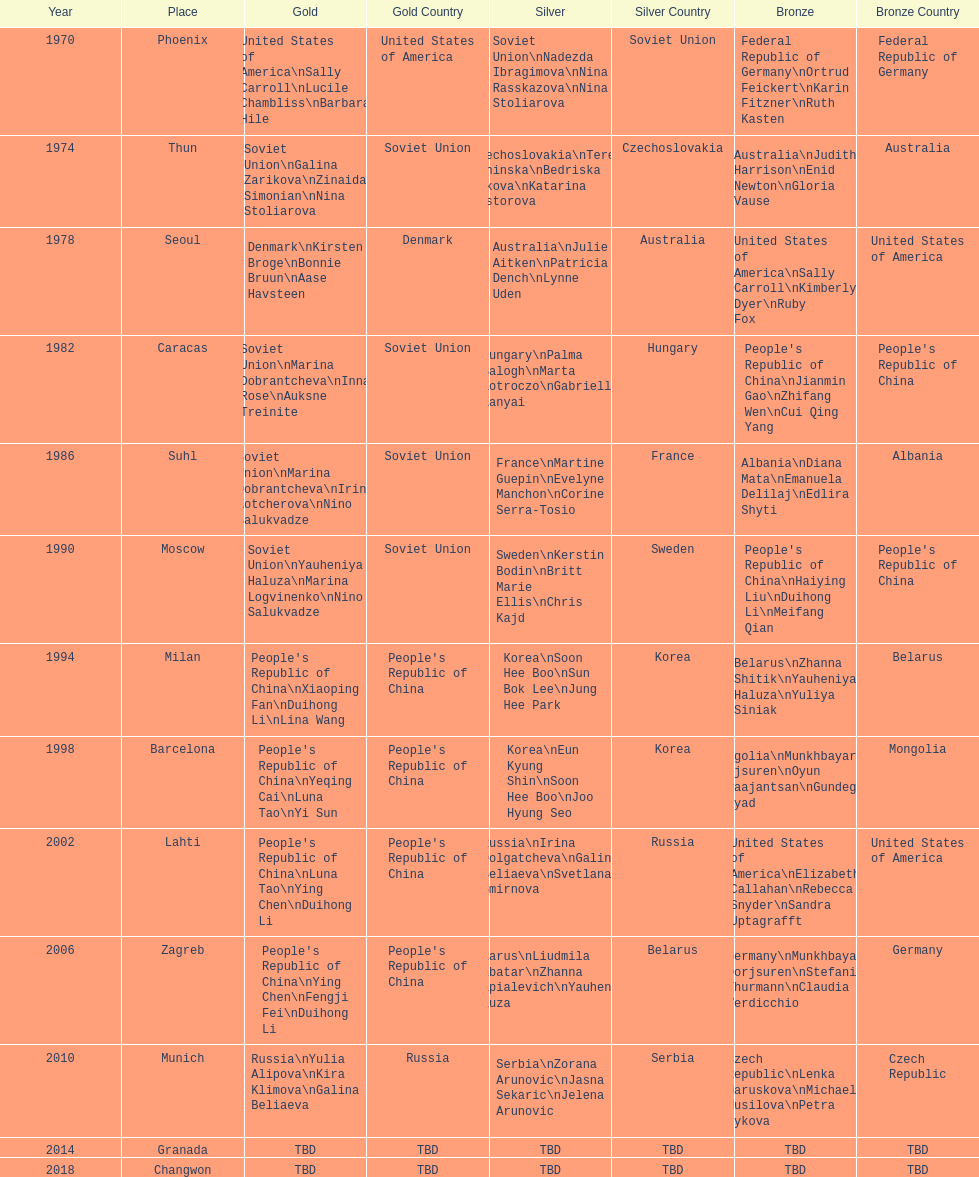How many world championships had the soviet union won first place in in the 25 metre pistol women's world championship? 4. 